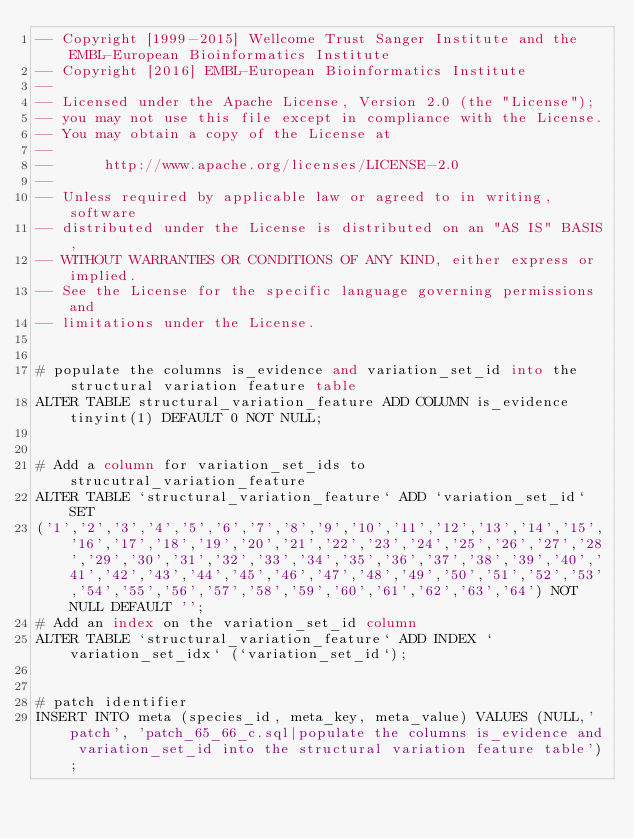<code> <loc_0><loc_0><loc_500><loc_500><_SQL_>-- Copyright [1999-2015] Wellcome Trust Sanger Institute and the EMBL-European Bioinformatics Institute
-- Copyright [2016] EMBL-European Bioinformatics Institute
-- 
-- Licensed under the Apache License, Version 2.0 (the "License");
-- you may not use this file except in compliance with the License.
-- You may obtain a copy of the License at
-- 
--      http://www.apache.org/licenses/LICENSE-2.0
-- 
-- Unless required by applicable law or agreed to in writing, software
-- distributed under the License is distributed on an "AS IS" BASIS,
-- WITHOUT WARRANTIES OR CONDITIONS OF ANY KIND, either express or implied.
-- See the License for the specific language governing permissions and
-- limitations under the License.


# populate the columns is_evidence and variation_set_id into the structural variation feature table
ALTER TABLE structural_variation_feature ADD COLUMN is_evidence tinyint(1) DEFAULT 0 NOT NULL;


# Add a column for variation_set_ids to strucutral_variation_feature
ALTER TABLE `structural_variation_feature` ADD `variation_set_id` SET 
('1','2','3','4','5','6','7','8','9','10','11','12','13','14','15','16','17','18','19','20','21','22','23','24','25','26','27','28','29','30','31','32','33','34','35','36','37','38','39','40','41','42','43','44','45','46','47','48','49','50','51','52','53','54','55','56','57','58','59','60','61','62','63','64') NOT NULL DEFAULT '';
# Add an index on the variation_set_id column
ALTER TABLE `structural_variation_feature` ADD INDEX `variation_set_idx` (`variation_set_id`);


# patch identifier
INSERT INTO meta (species_id, meta_key, meta_value) VALUES (NULL,'patch', 'patch_65_66_c.sql|populate the columns is_evidence and variation_set_id into the structural variation feature table');
</code> 